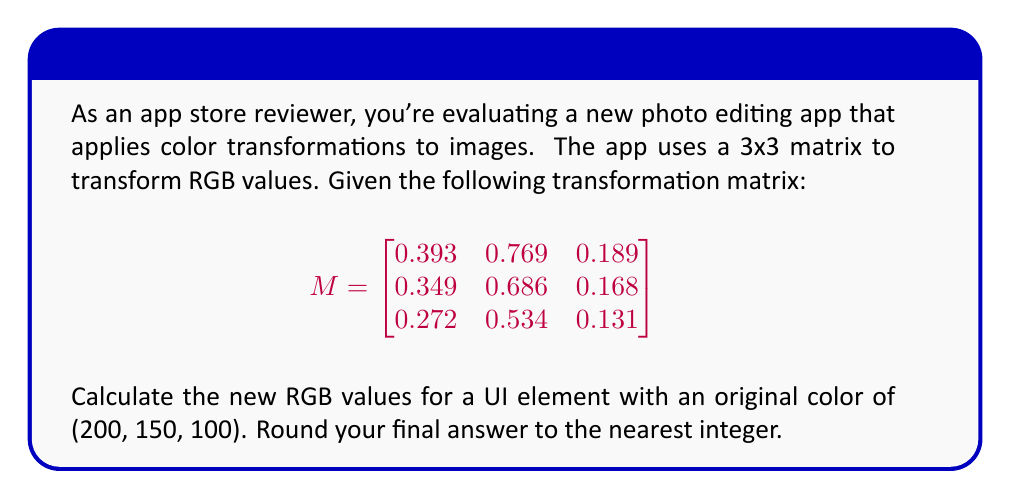Can you answer this question? To calculate the new RGB values, we need to multiply the transformation matrix by the original RGB vector:

1) First, let's set up the multiplication:

   $$
   \begin{bmatrix}
   0.393 & 0.769 & 0.189 \\
   0.349 & 0.686 & 0.168 \\
   0.272 & 0.534 & 0.131
   \end{bmatrix}
   \times
   \begin{bmatrix}
   200 \\
   150 \\
   100
   \end{bmatrix}
   $$

2) Now, let's perform the matrix multiplication:

   For the new R value:
   $$(0.393 \times 200) + (0.769 \times 150) + (0.189 \times 100) = 78.6 + 115.35 + 18.9 = 212.85$$

   For the new G value:
   $$(0.349 \times 200) + (0.686 \times 150) + (0.168 \times 100) = 69.8 + 102.9 + 16.8 = 189.5$$

   For the new B value:
   $$(0.272 \times 200) + (0.534 \times 150) + (0.131 \times 100) = 54.4 + 80.1 + 13.1 = 147.6$$

3) Rounding these values to the nearest integer:
   R: 213
   G: 190
   B: 148

Therefore, the new RGB color for the UI element is (213, 190, 148).
Answer: (213, 190, 148) 